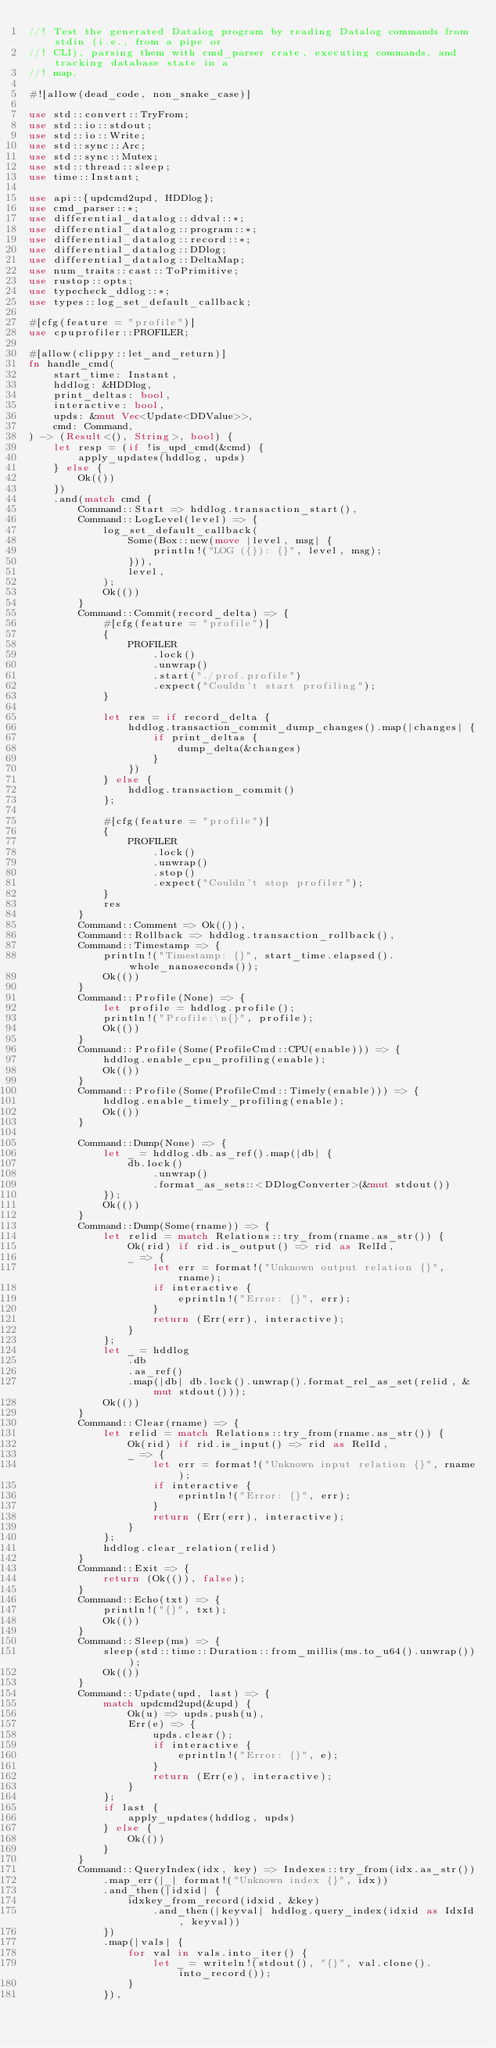Convert code to text. <code><loc_0><loc_0><loc_500><loc_500><_Rust_>//! Test the generated Datalog program by reading Datalog commands from stdin (i.e., from a pipe or
//! CLI), parsing them with cmd_parser crate, executing commands, and tracking database state in a
//! map.

#![allow(dead_code, non_snake_case)]

use std::convert::TryFrom;
use std::io::stdout;
use std::io::Write;
use std::sync::Arc;
use std::sync::Mutex;
use std::thread::sleep;
use time::Instant;

use api::{updcmd2upd, HDDlog};
use cmd_parser::*;
use differential_datalog::ddval::*;
use differential_datalog::program::*;
use differential_datalog::record::*;
use differential_datalog::DDlog;
use differential_datalog::DeltaMap;
use num_traits::cast::ToPrimitive;
use rustop::opts;
use typecheck_ddlog::*;
use types::log_set_default_callback;

#[cfg(feature = "profile")]
use cpuprofiler::PROFILER;

#[allow(clippy::let_and_return)]
fn handle_cmd(
    start_time: Instant,
    hddlog: &HDDlog,
    print_deltas: bool,
    interactive: bool,
    upds: &mut Vec<Update<DDValue>>,
    cmd: Command,
) -> (Result<(), String>, bool) {
    let resp = (if !is_upd_cmd(&cmd) {
        apply_updates(hddlog, upds)
    } else {
        Ok(())
    })
    .and(match cmd {
        Command::Start => hddlog.transaction_start(),
        Command::LogLevel(level) => {
            log_set_default_callback(
                Some(Box::new(move |level, msg| {
                    println!("LOG ({}): {}", level, msg);
                })),
                level,
            );
            Ok(())
        }
        Command::Commit(record_delta) => {
            #[cfg(feature = "profile")]
            {
                PROFILER
                    .lock()
                    .unwrap()
                    .start("./prof.profile")
                    .expect("Couldn't start profiling");
            }

            let res = if record_delta {
                hddlog.transaction_commit_dump_changes().map(|changes| {
                    if print_deltas {
                        dump_delta(&changes)
                    }
                })
            } else {
                hddlog.transaction_commit()
            };

            #[cfg(feature = "profile")]
            {
                PROFILER
                    .lock()
                    .unwrap()
                    .stop()
                    .expect("Couldn't stop profiler");
            }
            res
        }
        Command::Comment => Ok(()),
        Command::Rollback => hddlog.transaction_rollback(),
        Command::Timestamp => {
            println!("Timestamp: {}", start_time.elapsed().whole_nanoseconds());
            Ok(())
        }
        Command::Profile(None) => {
            let profile = hddlog.profile();
            println!("Profile:\n{}", profile);
            Ok(())
        }
        Command::Profile(Some(ProfileCmd::CPU(enable))) => {
            hddlog.enable_cpu_profiling(enable);
            Ok(())
        }
        Command::Profile(Some(ProfileCmd::Timely(enable))) => {
            hddlog.enable_timely_profiling(enable);
            Ok(())
        }

        Command::Dump(None) => {
            let _ = hddlog.db.as_ref().map(|db| {
                db.lock()
                    .unwrap()
                    .format_as_sets::<DDlogConverter>(&mut stdout())
            });
            Ok(())
        }
        Command::Dump(Some(rname)) => {
            let relid = match Relations::try_from(rname.as_str()) {
                Ok(rid) if rid.is_output() => rid as RelId,
                _ => {
                    let err = format!("Unknown output relation {}", rname);
                    if interactive {
                        eprintln!("Error: {}", err);
                    }
                    return (Err(err), interactive);
                }
            };
            let _ = hddlog
                .db
                .as_ref()
                .map(|db| db.lock().unwrap().format_rel_as_set(relid, &mut stdout()));
            Ok(())
        }
        Command::Clear(rname) => {
            let relid = match Relations::try_from(rname.as_str()) {
                Ok(rid) if rid.is_input() => rid as RelId,
                _ => {
                    let err = format!("Unknown input relation {}", rname);
                    if interactive {
                        eprintln!("Error: {}", err);
                    }
                    return (Err(err), interactive);
                }
            };
            hddlog.clear_relation(relid)
        }
        Command::Exit => {
            return (Ok(()), false);
        }
        Command::Echo(txt) => {
            println!("{}", txt);
            Ok(())
        }
        Command::Sleep(ms) => {
            sleep(std::time::Duration::from_millis(ms.to_u64().unwrap()));
            Ok(())
        }
        Command::Update(upd, last) => {
            match updcmd2upd(&upd) {
                Ok(u) => upds.push(u),
                Err(e) => {
                    upds.clear();
                    if interactive {
                        eprintln!("Error: {}", e);
                    }
                    return (Err(e), interactive);
                }
            };
            if last {
                apply_updates(hddlog, upds)
            } else {
                Ok(())
            }
        }
        Command::QueryIndex(idx, key) => Indexes::try_from(idx.as_str())
            .map_err(|_| format!("Unknown index {}", idx))
            .and_then(|idxid| {
                idxkey_from_record(idxid, &key)
                    .and_then(|keyval| hddlog.query_index(idxid as IdxId, keyval))
            })
            .map(|vals| {
                for val in vals.into_iter() {
                    let _ = writeln!(stdout(), "{}", val.clone().into_record());
                }
            }),</code> 